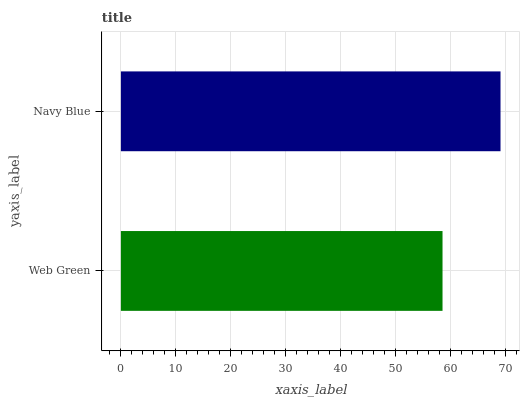Is Web Green the minimum?
Answer yes or no. Yes. Is Navy Blue the maximum?
Answer yes or no. Yes. Is Navy Blue the minimum?
Answer yes or no. No. Is Navy Blue greater than Web Green?
Answer yes or no. Yes. Is Web Green less than Navy Blue?
Answer yes or no. Yes. Is Web Green greater than Navy Blue?
Answer yes or no. No. Is Navy Blue less than Web Green?
Answer yes or no. No. Is Navy Blue the high median?
Answer yes or no. Yes. Is Web Green the low median?
Answer yes or no. Yes. Is Web Green the high median?
Answer yes or no. No. Is Navy Blue the low median?
Answer yes or no. No. 